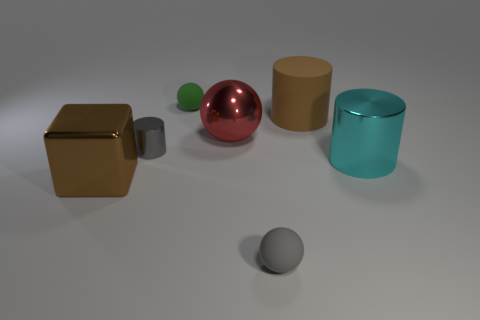Do the cube and the matte cylinder have the same color?
Your answer should be very brief. Yes. What is the shape of the big metal thing that is the same color as the big matte cylinder?
Offer a very short reply. Cube. Are any big cyan rubber blocks visible?
Provide a succinct answer. No. What number of green balls are the same size as the green thing?
Keep it short and to the point. 0. What number of big metal things are right of the matte cylinder and left of the big cyan cylinder?
Offer a very short reply. 0. There is a cylinder on the left side of the gray matte thing; is it the same size as the big metallic cylinder?
Make the answer very short. No. Are there any rubber cylinders of the same color as the shiny block?
Your response must be concise. Yes. What is the size of the ball that is the same material as the cyan thing?
Keep it short and to the point. Large. Are there more red shiny balls left of the small cylinder than small gray objects that are in front of the big brown metal cube?
Offer a very short reply. No. What number of other objects are there of the same material as the large block?
Offer a very short reply. 3. 